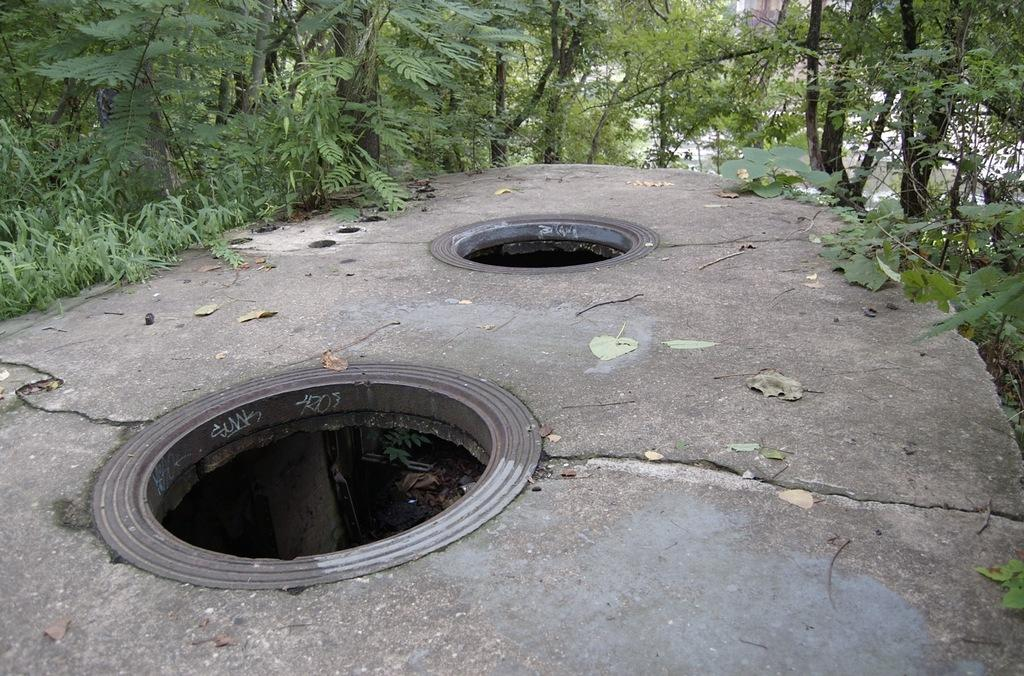Where might the image have been taken? The image might have been taken outside of the city. What can be seen on the floor in the middle of the image? There are two holes on the floor in the middle of the image. What type of natural environment is visible in the background of the image? There are trees visible in the background of the image. What type of skirt is the pig wearing in the image? There is no pig or skirt present in the image. 